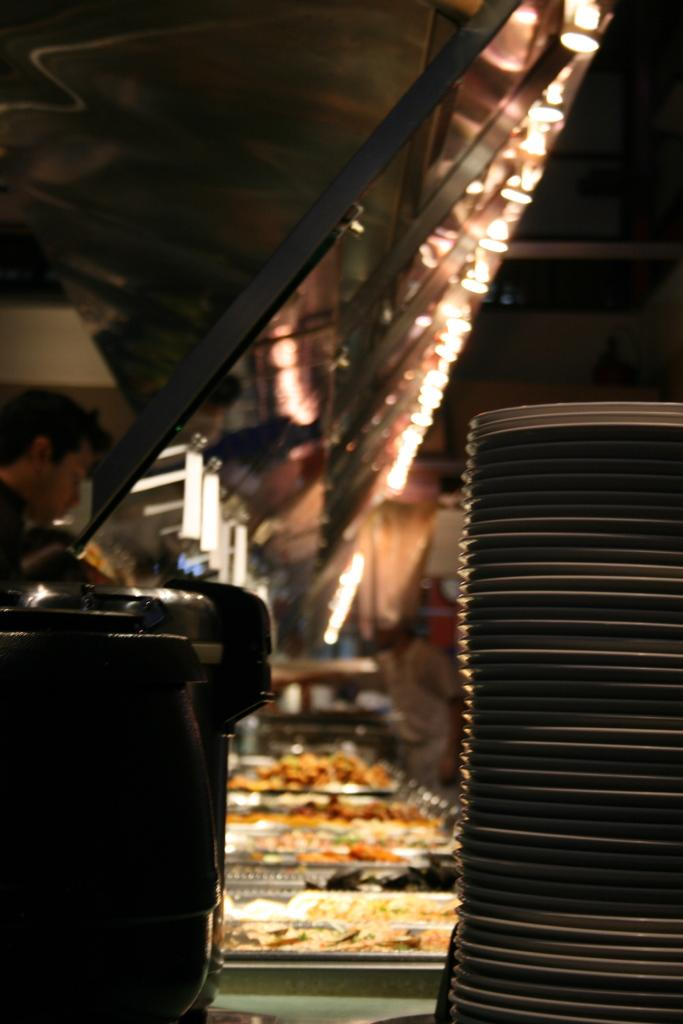What can be found in the trays in the image? There are food items in the trays in the image. What is used to serve the food items? There are plates in the image. What is located beside the plates? There is an object beside the plates. Who is present in the image? There are people in the image. What can be seen providing illumination in the image? There are lights visible in the image. What type of structure is present in the image? There is a shed in the image. Can you describe the position of the toe in the image? There is no toe present in the image. What type of trail can be seen in the image? There is no trail visible in the image. 